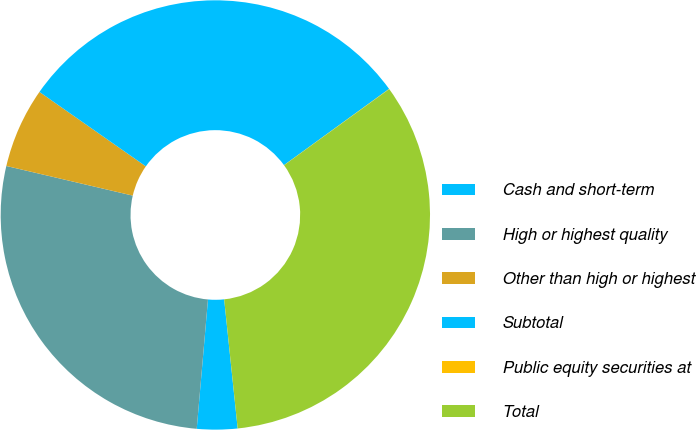Convert chart. <chart><loc_0><loc_0><loc_500><loc_500><pie_chart><fcel>Cash and short-term<fcel>High or highest quality<fcel>Other than high or highest<fcel>Subtotal<fcel>Public equity securities at<fcel>Total<nl><fcel>3.04%<fcel>27.28%<fcel>6.05%<fcel>30.29%<fcel>0.02%<fcel>33.31%<nl></chart> 